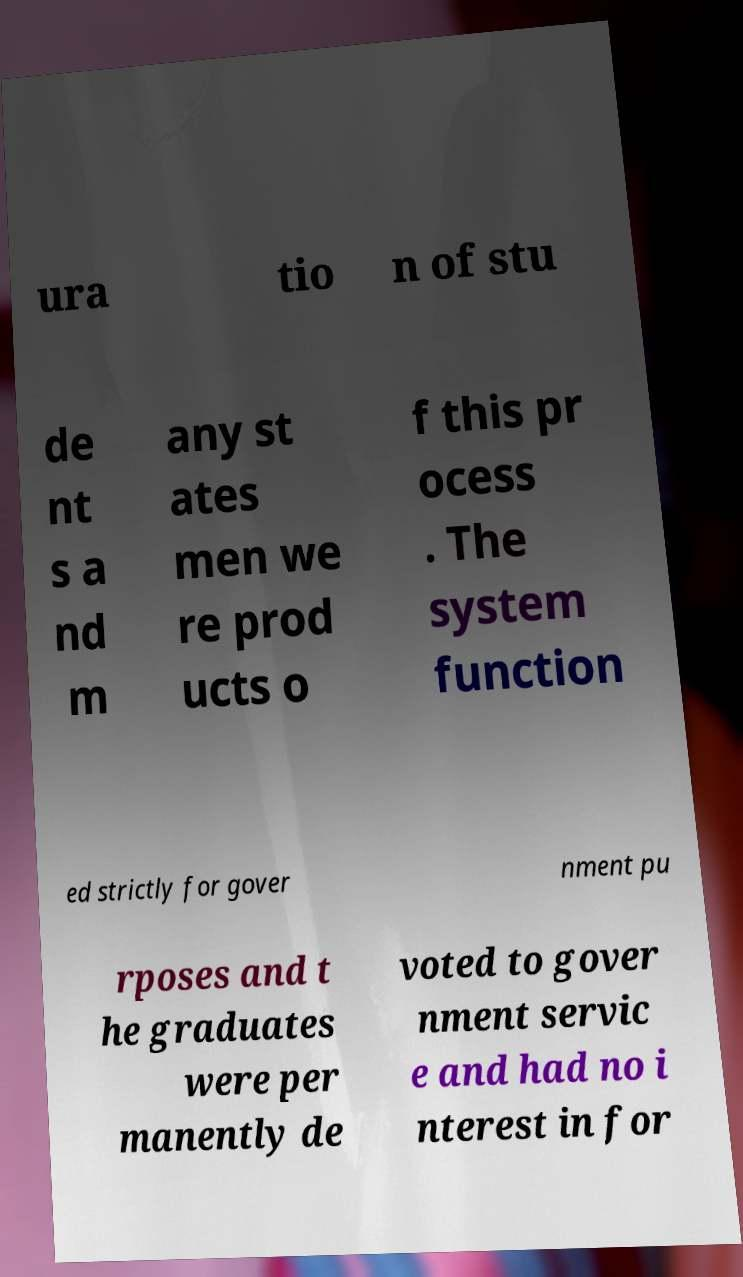Could you assist in decoding the text presented in this image and type it out clearly? ura tio n of stu de nt s a nd m any st ates men we re prod ucts o f this pr ocess . The system function ed strictly for gover nment pu rposes and t he graduates were per manently de voted to gover nment servic e and had no i nterest in for 